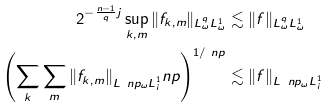<formula> <loc_0><loc_0><loc_500><loc_500>2 ^ { - \frac { n - 1 } { q } j } \sup _ { k , m } \| f _ { k , m } \| _ { L ^ { q } _ { \omega } L ^ { 1 } _ { \omega } } & \lesssim \| f \| _ { L ^ { q } _ { \omega } L ^ { 1 } _ { \omega } } \\ \left ( \sum _ { k } \sum _ { m } \| f _ { k , m } \| _ { L ^ { \ } n p _ { \omega } L ^ { 1 } _ { i } } ^ { \ } n p \right ) ^ { 1 / \ n p } & \lesssim \| f \| _ { L ^ { \ } n p _ { \omega } L ^ { 1 } _ { i } }</formula> 